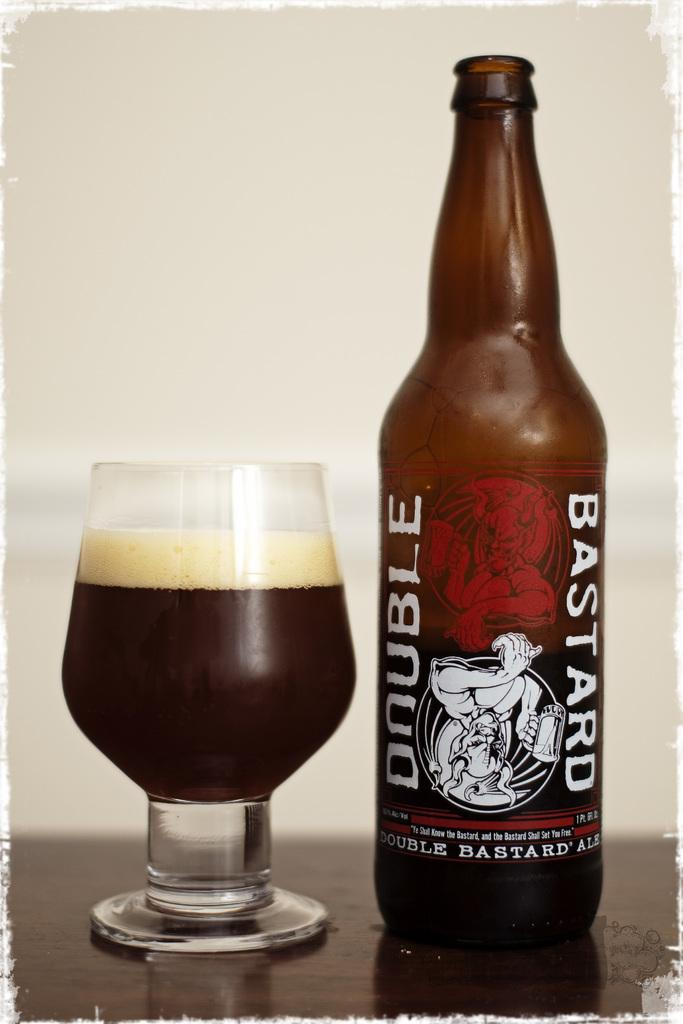<image>
Render a clear and concise summary of the photo. the word bastard is on the brown beer bottle 